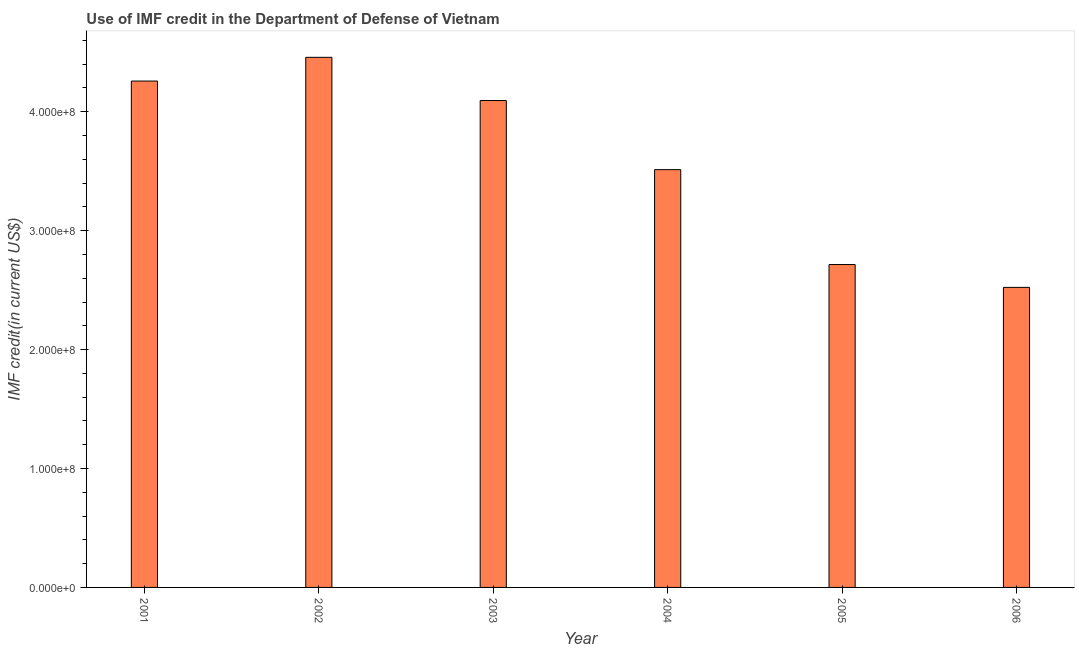Does the graph contain grids?
Make the answer very short. No. What is the title of the graph?
Make the answer very short. Use of IMF credit in the Department of Defense of Vietnam. What is the label or title of the Y-axis?
Ensure brevity in your answer.  IMF credit(in current US$). What is the use of imf credit in dod in 2002?
Give a very brief answer. 4.46e+08. Across all years, what is the maximum use of imf credit in dod?
Offer a very short reply. 4.46e+08. Across all years, what is the minimum use of imf credit in dod?
Give a very brief answer. 2.52e+08. In which year was the use of imf credit in dod maximum?
Ensure brevity in your answer.  2002. What is the sum of the use of imf credit in dod?
Your answer should be very brief. 2.16e+09. What is the difference between the use of imf credit in dod in 2004 and 2005?
Offer a very short reply. 7.98e+07. What is the average use of imf credit in dod per year?
Your answer should be very brief. 3.59e+08. What is the median use of imf credit in dod?
Your answer should be very brief. 3.80e+08. Do a majority of the years between 2001 and 2006 (inclusive) have use of imf credit in dod greater than 320000000 US$?
Provide a short and direct response. Yes. What is the ratio of the use of imf credit in dod in 2003 to that in 2004?
Provide a short and direct response. 1.17. What is the difference between the highest and the second highest use of imf credit in dod?
Ensure brevity in your answer.  1.99e+07. What is the difference between the highest and the lowest use of imf credit in dod?
Ensure brevity in your answer.  1.93e+08. In how many years, is the use of imf credit in dod greater than the average use of imf credit in dod taken over all years?
Your answer should be very brief. 3. What is the IMF credit(in current US$) in 2001?
Give a very brief answer. 4.26e+08. What is the IMF credit(in current US$) of 2002?
Provide a short and direct response. 4.46e+08. What is the IMF credit(in current US$) in 2003?
Your answer should be very brief. 4.09e+08. What is the IMF credit(in current US$) of 2004?
Make the answer very short. 3.51e+08. What is the IMF credit(in current US$) of 2005?
Offer a very short reply. 2.72e+08. What is the IMF credit(in current US$) of 2006?
Ensure brevity in your answer.  2.52e+08. What is the difference between the IMF credit(in current US$) in 2001 and 2002?
Make the answer very short. -1.99e+07. What is the difference between the IMF credit(in current US$) in 2001 and 2003?
Ensure brevity in your answer.  1.64e+07. What is the difference between the IMF credit(in current US$) in 2001 and 2004?
Your answer should be compact. 7.45e+07. What is the difference between the IMF credit(in current US$) in 2001 and 2005?
Provide a succinct answer. 1.54e+08. What is the difference between the IMF credit(in current US$) in 2001 and 2006?
Ensure brevity in your answer.  1.74e+08. What is the difference between the IMF credit(in current US$) in 2002 and 2003?
Your answer should be very brief. 3.63e+07. What is the difference between the IMF credit(in current US$) in 2002 and 2004?
Your response must be concise. 9.45e+07. What is the difference between the IMF credit(in current US$) in 2002 and 2005?
Offer a terse response. 1.74e+08. What is the difference between the IMF credit(in current US$) in 2002 and 2006?
Offer a terse response. 1.93e+08. What is the difference between the IMF credit(in current US$) in 2003 and 2004?
Provide a short and direct response. 5.81e+07. What is the difference between the IMF credit(in current US$) in 2003 and 2005?
Your answer should be very brief. 1.38e+08. What is the difference between the IMF credit(in current US$) in 2003 and 2006?
Offer a very short reply. 1.57e+08. What is the difference between the IMF credit(in current US$) in 2004 and 2005?
Provide a short and direct response. 7.98e+07. What is the difference between the IMF credit(in current US$) in 2004 and 2006?
Provide a succinct answer. 9.90e+07. What is the difference between the IMF credit(in current US$) in 2005 and 2006?
Ensure brevity in your answer.  1.92e+07. What is the ratio of the IMF credit(in current US$) in 2001 to that in 2002?
Give a very brief answer. 0.95. What is the ratio of the IMF credit(in current US$) in 2001 to that in 2003?
Provide a short and direct response. 1.04. What is the ratio of the IMF credit(in current US$) in 2001 to that in 2004?
Give a very brief answer. 1.21. What is the ratio of the IMF credit(in current US$) in 2001 to that in 2005?
Offer a terse response. 1.57. What is the ratio of the IMF credit(in current US$) in 2001 to that in 2006?
Offer a terse response. 1.69. What is the ratio of the IMF credit(in current US$) in 2002 to that in 2003?
Offer a terse response. 1.09. What is the ratio of the IMF credit(in current US$) in 2002 to that in 2004?
Keep it short and to the point. 1.27. What is the ratio of the IMF credit(in current US$) in 2002 to that in 2005?
Make the answer very short. 1.64. What is the ratio of the IMF credit(in current US$) in 2002 to that in 2006?
Offer a very short reply. 1.77. What is the ratio of the IMF credit(in current US$) in 2003 to that in 2004?
Make the answer very short. 1.17. What is the ratio of the IMF credit(in current US$) in 2003 to that in 2005?
Offer a very short reply. 1.51. What is the ratio of the IMF credit(in current US$) in 2003 to that in 2006?
Offer a very short reply. 1.62. What is the ratio of the IMF credit(in current US$) in 2004 to that in 2005?
Your answer should be compact. 1.29. What is the ratio of the IMF credit(in current US$) in 2004 to that in 2006?
Give a very brief answer. 1.39. What is the ratio of the IMF credit(in current US$) in 2005 to that in 2006?
Provide a short and direct response. 1.08. 